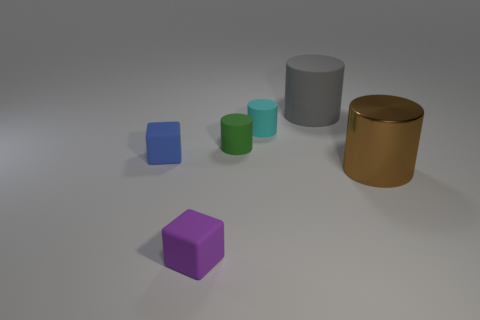Subtract all tiny green cylinders. How many cylinders are left? 3 Subtract all green cylinders. How many cylinders are left? 3 Add 3 tiny cyan rubber cylinders. How many objects exist? 9 Subtract all cyan cylinders. Subtract all cyan spheres. How many cylinders are left? 3 Subtract all cylinders. How many objects are left? 2 Subtract 1 green cylinders. How many objects are left? 5 Subtract all red rubber things. Subtract all big brown shiny cylinders. How many objects are left? 5 Add 6 green things. How many green things are left? 7 Add 5 green matte cylinders. How many green matte cylinders exist? 6 